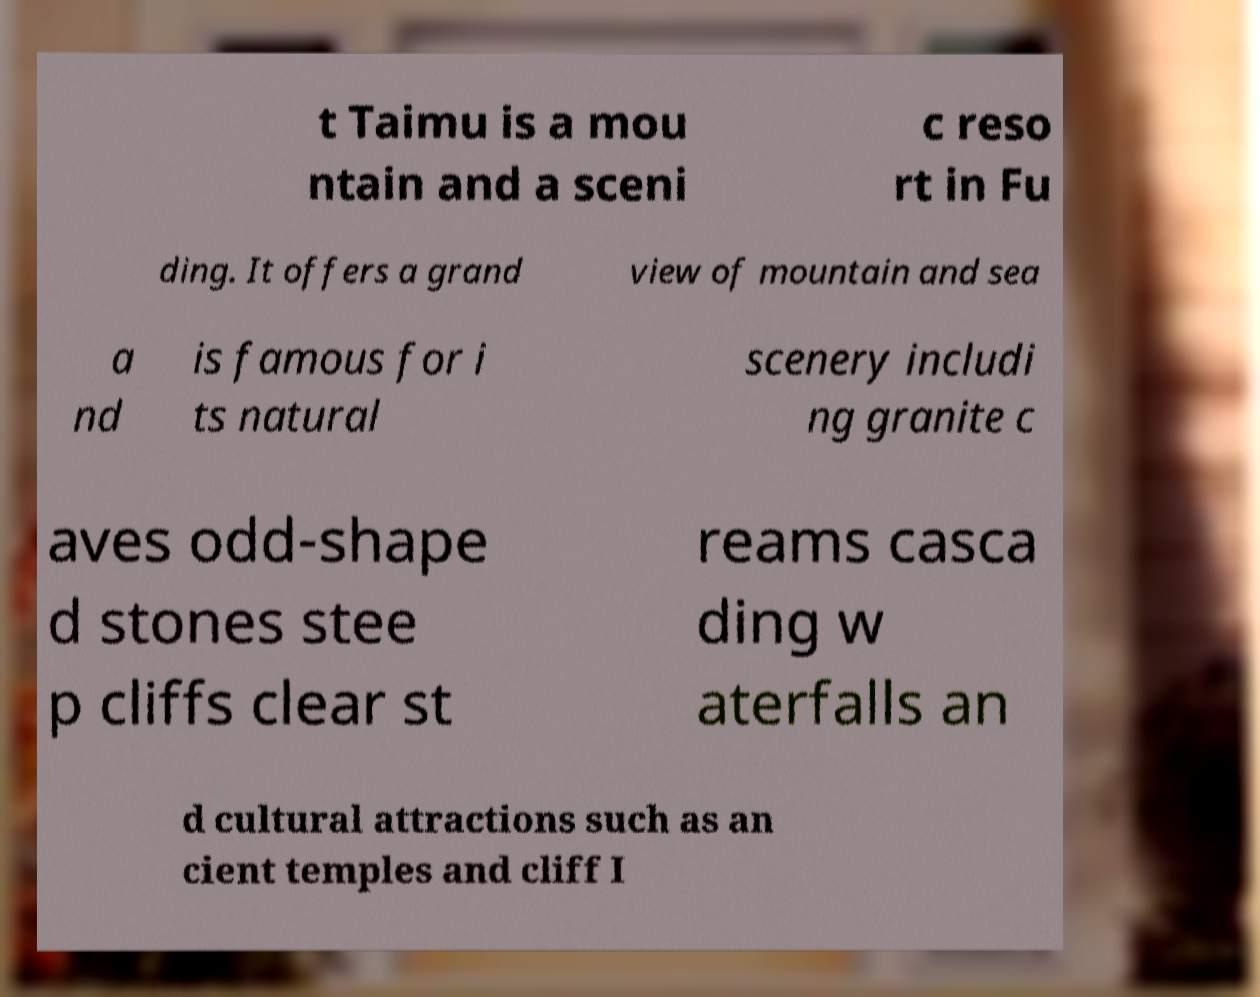I need the written content from this picture converted into text. Can you do that? t Taimu is a mou ntain and a sceni c reso rt in Fu ding. It offers a grand view of mountain and sea a nd is famous for i ts natural scenery includi ng granite c aves odd-shape d stones stee p cliffs clear st reams casca ding w aterfalls an d cultural attractions such as an cient temples and cliff I 